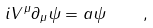Convert formula to latex. <formula><loc_0><loc_0><loc_500><loc_500>i V ^ { \mu } \partial _ { \mu } \psi = a \psi \quad ,</formula> 